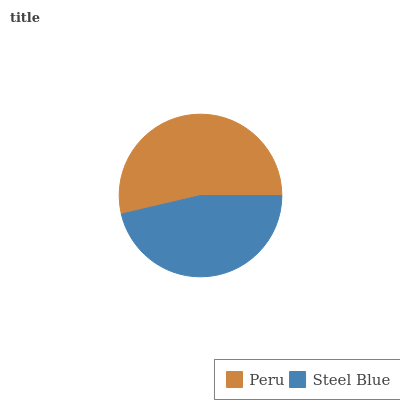Is Steel Blue the minimum?
Answer yes or no. Yes. Is Peru the maximum?
Answer yes or no. Yes. Is Steel Blue the maximum?
Answer yes or no. No. Is Peru greater than Steel Blue?
Answer yes or no. Yes. Is Steel Blue less than Peru?
Answer yes or no. Yes. Is Steel Blue greater than Peru?
Answer yes or no. No. Is Peru less than Steel Blue?
Answer yes or no. No. Is Peru the high median?
Answer yes or no. Yes. Is Steel Blue the low median?
Answer yes or no. Yes. Is Steel Blue the high median?
Answer yes or no. No. Is Peru the low median?
Answer yes or no. No. 